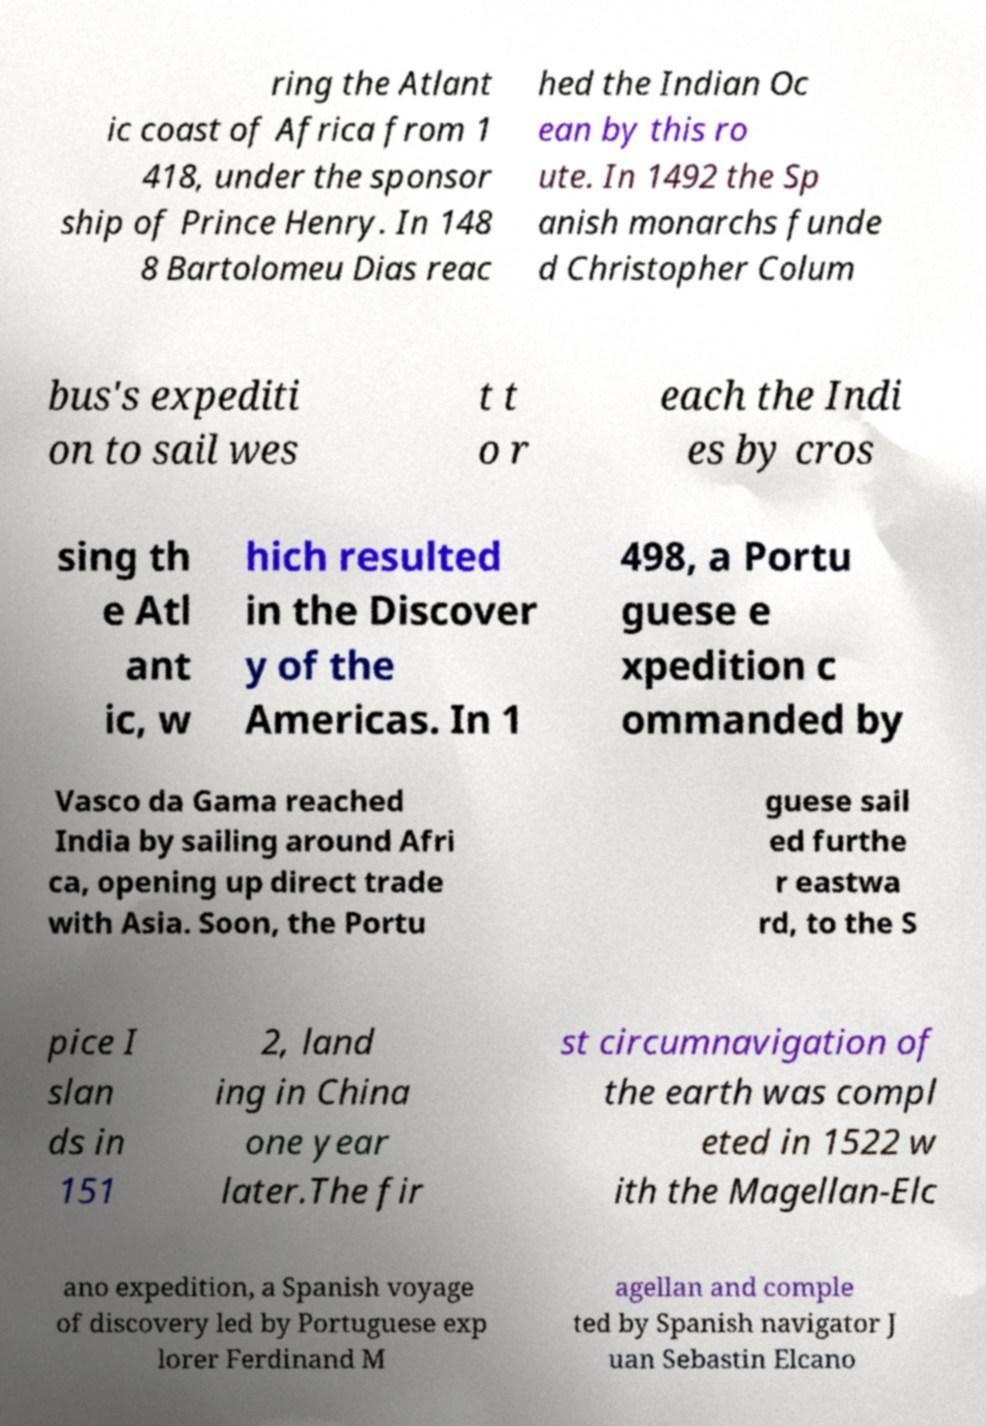What messages or text are displayed in this image? I need them in a readable, typed format. ring the Atlant ic coast of Africa from 1 418, under the sponsor ship of Prince Henry. In 148 8 Bartolomeu Dias reac hed the Indian Oc ean by this ro ute. In 1492 the Sp anish monarchs funde d Christopher Colum bus's expediti on to sail wes t t o r each the Indi es by cros sing th e Atl ant ic, w hich resulted in the Discover y of the Americas. In 1 498, a Portu guese e xpedition c ommanded by Vasco da Gama reached India by sailing around Afri ca, opening up direct trade with Asia. Soon, the Portu guese sail ed furthe r eastwa rd, to the S pice I slan ds in 151 2, land ing in China one year later.The fir st circumnavigation of the earth was compl eted in 1522 w ith the Magellan-Elc ano expedition, a Spanish voyage of discovery led by Portuguese exp lorer Ferdinand M agellan and comple ted by Spanish navigator J uan Sebastin Elcano 